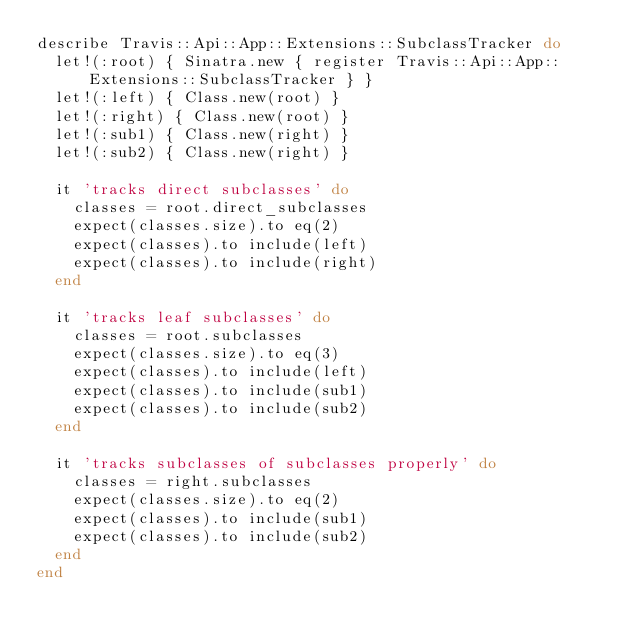<code> <loc_0><loc_0><loc_500><loc_500><_Ruby_>describe Travis::Api::App::Extensions::SubclassTracker do
  let!(:root) { Sinatra.new { register Travis::Api::App::Extensions::SubclassTracker } }
  let!(:left) { Class.new(root) }
  let!(:right) { Class.new(root) }
  let!(:sub1) { Class.new(right) }
  let!(:sub2) { Class.new(right) }

  it 'tracks direct subclasses' do
    classes = root.direct_subclasses
    expect(classes.size).to eq(2)
    expect(classes).to include(left)
    expect(classes).to include(right)
  end

  it 'tracks leaf subclasses' do
    classes = root.subclasses
    expect(classes.size).to eq(3)
    expect(classes).to include(left)
    expect(classes).to include(sub1)
    expect(classes).to include(sub2)
  end

  it 'tracks subclasses of subclasses properly' do
    classes = right.subclasses
    expect(classes.size).to eq(2)
    expect(classes).to include(sub1)
    expect(classes).to include(sub2)
  end
end
</code> 